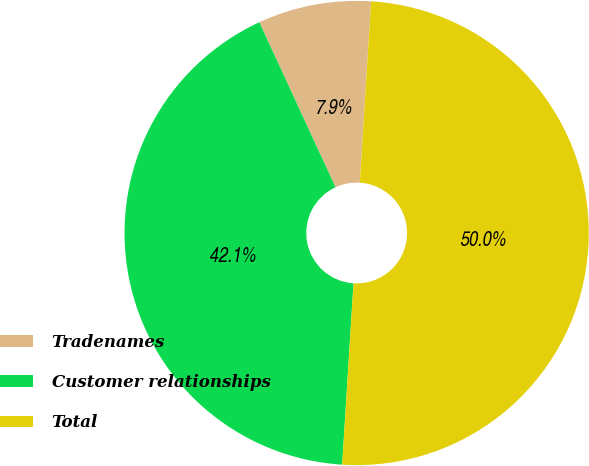Convert chart. <chart><loc_0><loc_0><loc_500><loc_500><pie_chart><fcel>Tradenames<fcel>Customer relationships<fcel>Total<nl><fcel>7.88%<fcel>42.12%<fcel>50.0%<nl></chart> 